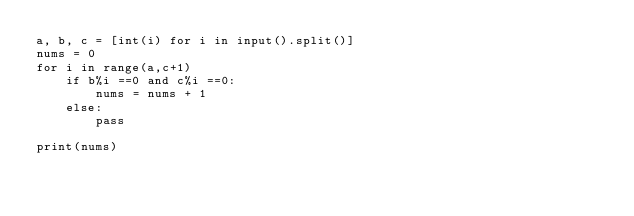<code> <loc_0><loc_0><loc_500><loc_500><_Python_>a, b, c = [int(i) for i in input().split()]
nums = 0
for i in range(a,c+1)
    if b%i ==0 and c%i ==0:
        nums = nums + 1
    else:
        pass
   
print(nums)</code> 